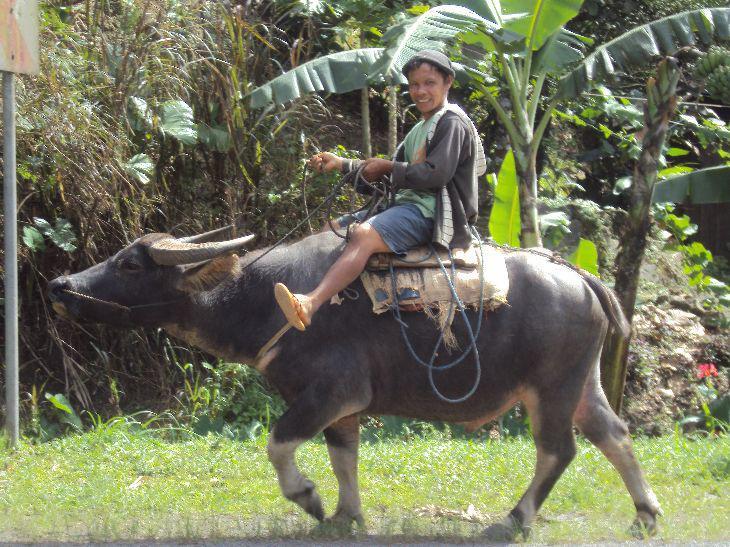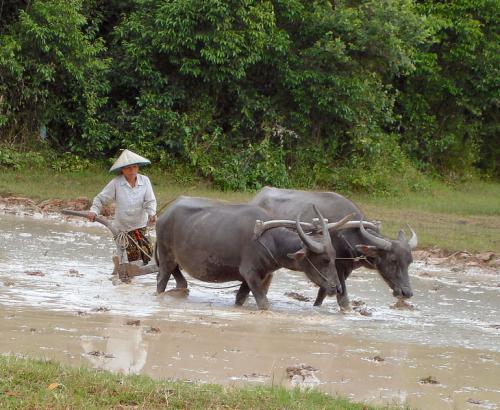The first image is the image on the left, the second image is the image on the right. Considering the images on both sides, is "One image shows only one person, who is wearing a cone-shaped hat and holding a stick, with at least one water buffalo standing in a wet area." valid? Answer yes or no. Yes. The first image is the image on the left, the second image is the image on the right. Assess this claim about the two images: "The left image contains two water buffaloes.". Correct or not? Answer yes or no. No. 